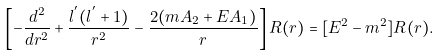Convert formula to latex. <formula><loc_0><loc_0><loc_500><loc_500>\left [ - \frac { d ^ { 2 } } { d r ^ { 2 } } + \frac { l ^ { ^ { \prime } } ( l ^ { ^ { \prime } } + 1 ) } { r ^ { 2 } } - \frac { 2 ( m A _ { 2 } + E A _ { 1 } ) } { r } \right ] R ( r ) = [ E ^ { 2 } - m ^ { 2 } ] R ( r ) .</formula> 